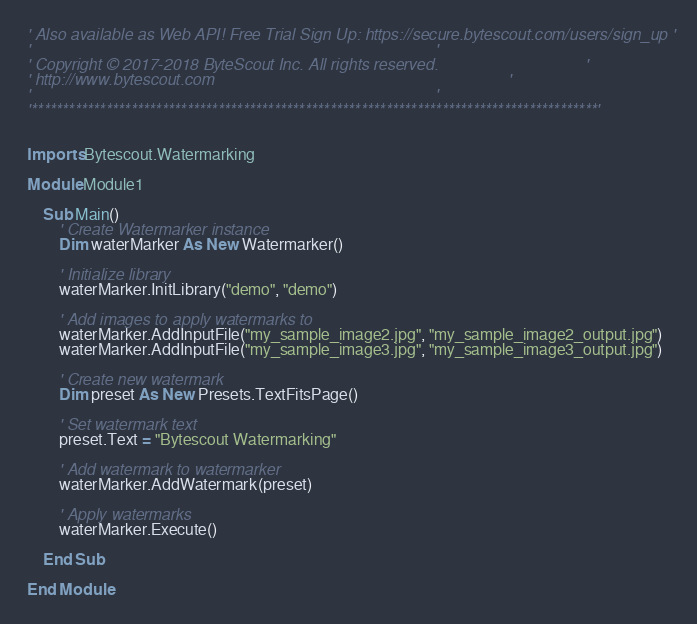<code> <loc_0><loc_0><loc_500><loc_500><_VisualBasic_>' Also available as Web API! Free Trial Sign Up: https://secure.bytescout.com/users/sign_up '
'                                                                                           '
' Copyright © 2017-2018 ByteScout Inc. All rights reserved.                                 '
' http://www.bytescout.com                                                                  '
'                                                                                           '
'*******************************************************************************************'


Imports Bytescout.Watermarking

Module Module1

    Sub Main()
        ' Create Watermarker instance
        Dim waterMarker As New Watermarker()

        ' Initialize library
        waterMarker.InitLibrary("demo", "demo")

        ' Add images to apply watermarks to
        waterMarker.AddInputFile("my_sample_image2.jpg", "my_sample_image2_output.jpg")
        waterMarker.AddInputFile("my_sample_image3.jpg", "my_sample_image3_output.jpg")

        ' Create new watermark
        Dim preset As New Presets.TextFitsPage()

        ' Set watermark text
        preset.Text = "Bytescout Watermarking"

        ' Add watermark to watermarker
        waterMarker.AddWatermark(preset)

        ' Apply watermarks
        waterMarker.Execute()

    End Sub

End Module
</code> 